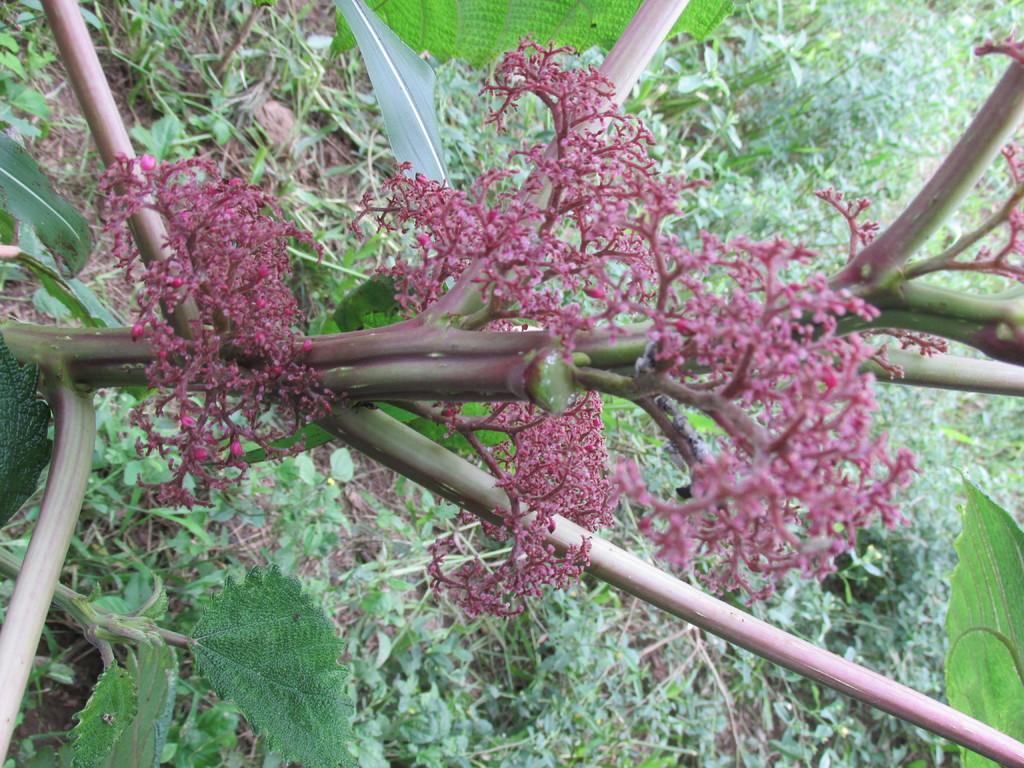Please provide a concise description of this image. In this picture we can see a plant and grass on the ground. 